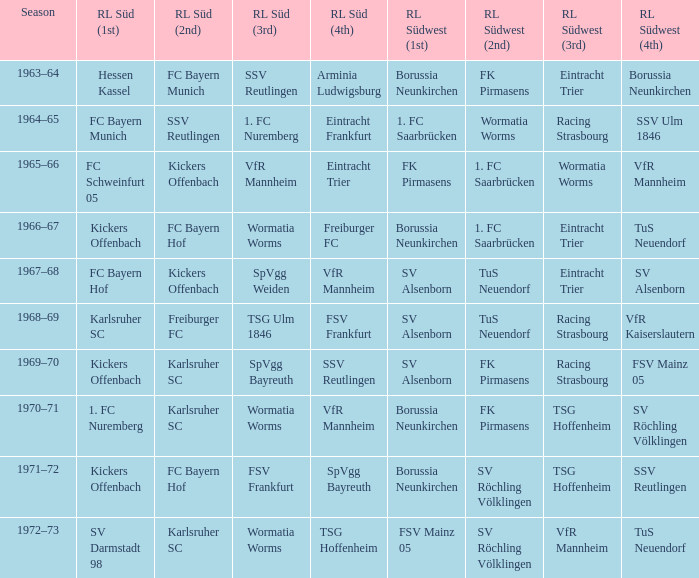What season did SV Darmstadt 98 end up at RL Süd (1st)? 1972–73. 